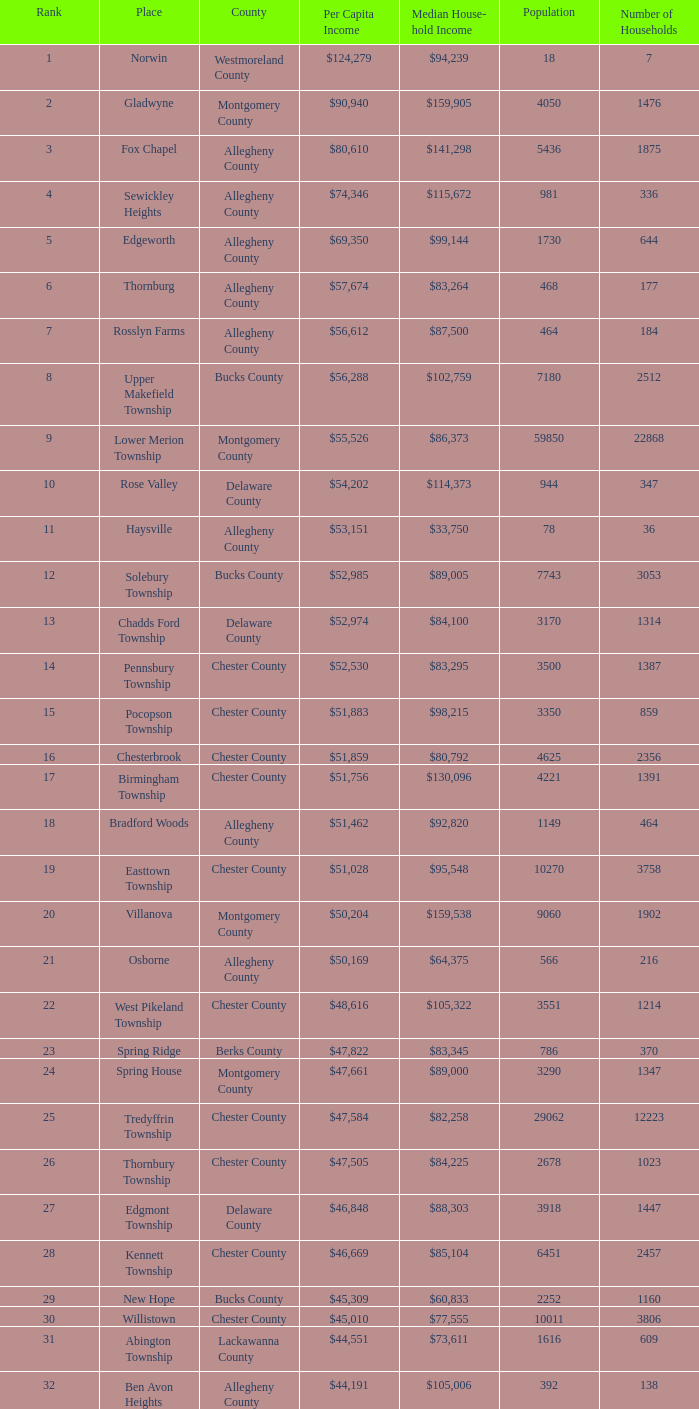In what county are there 2053 households? Chester County. 